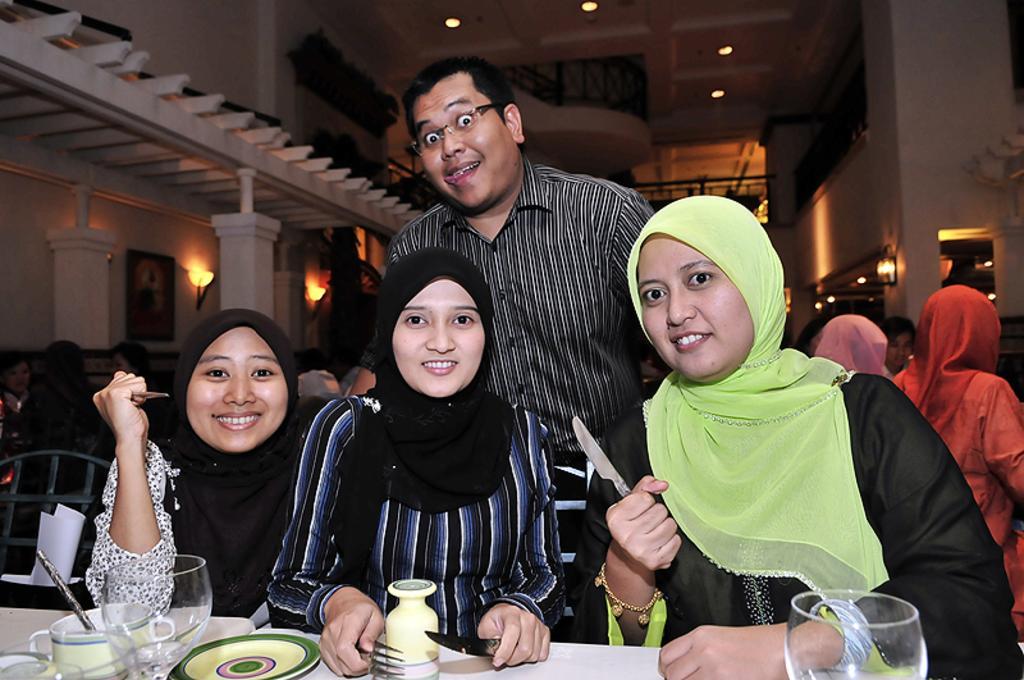Please provide a concise description of this image. At the bottom of the image there is a table, on the table there are some glasses and plates. Behind the table three women are sitting and smiling and holding knives and fork. Behind them a man is standing. Background of the image few people are sitting. At the top of the image there is wall, on the wall there are some frames and lights and their ceiling, on the ceiling there are some lights. 